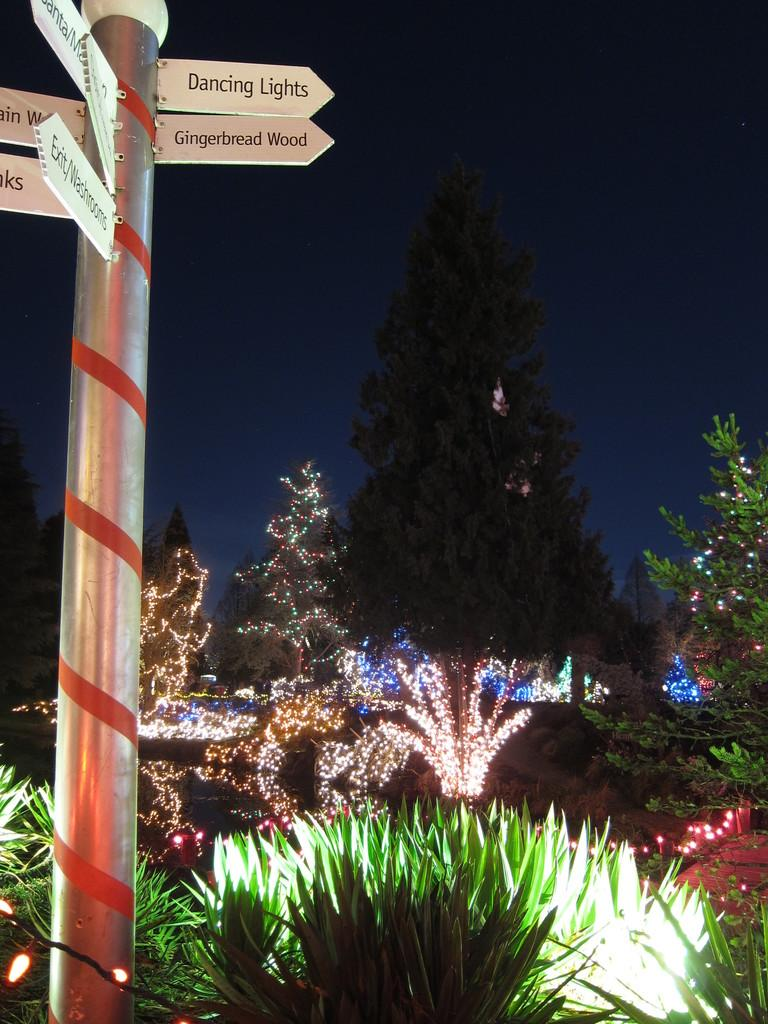What is the main object in the image? There is a pole in the image. What is attached to the pole? There are name boards attached to the pole. What can be seen in the background of the image? There are plants and decorative lights on the trees in the background of the image. What is visible in the sky in the image? The sky is visible in the background of the image. Can you tell me how many berries are hanging from the pole in the image? There are no berries present in the image; it features a pole with name boards and a background with plants and decorative lights on the trees. What type of current is flowing through the pole in the image? There is no indication of any current flowing through the pole in the image. 